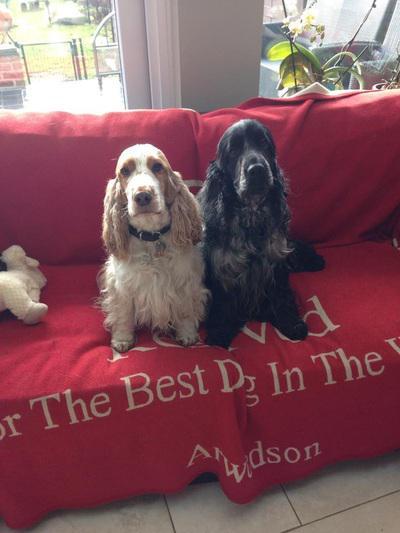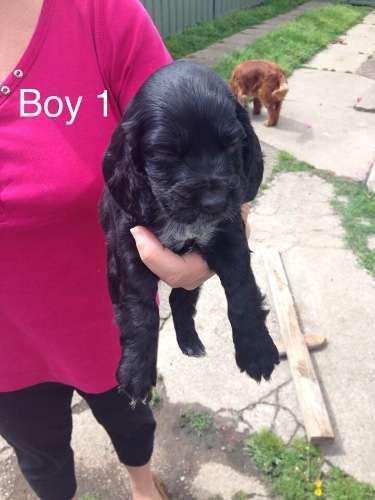The first image is the image on the left, the second image is the image on the right. Examine the images to the left and right. Is the description "There are only two dogs in total." accurate? Answer yes or no. No. The first image is the image on the left, the second image is the image on the right. Evaluate the accuracy of this statement regarding the images: "Two spaniels are next to each other on a sofa in one image, and the other image shows one puppy in the foreground.". Is it true? Answer yes or no. Yes. 